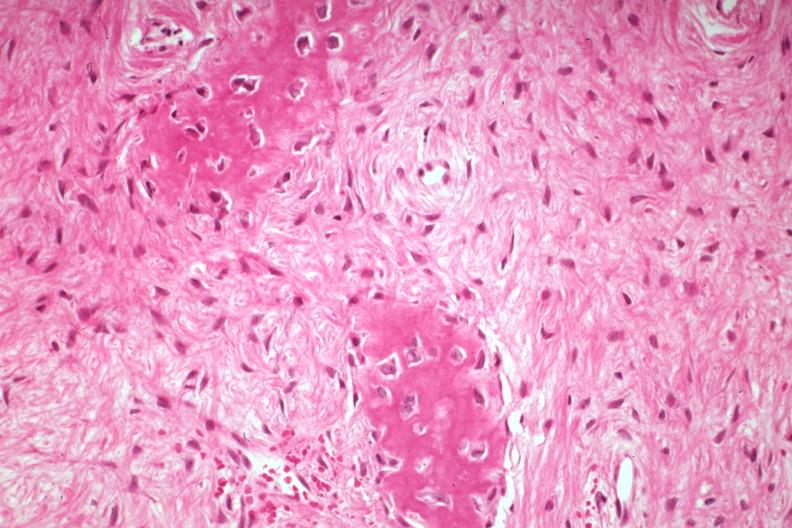what is present?
Answer the question using a single word or phrase. Joints 